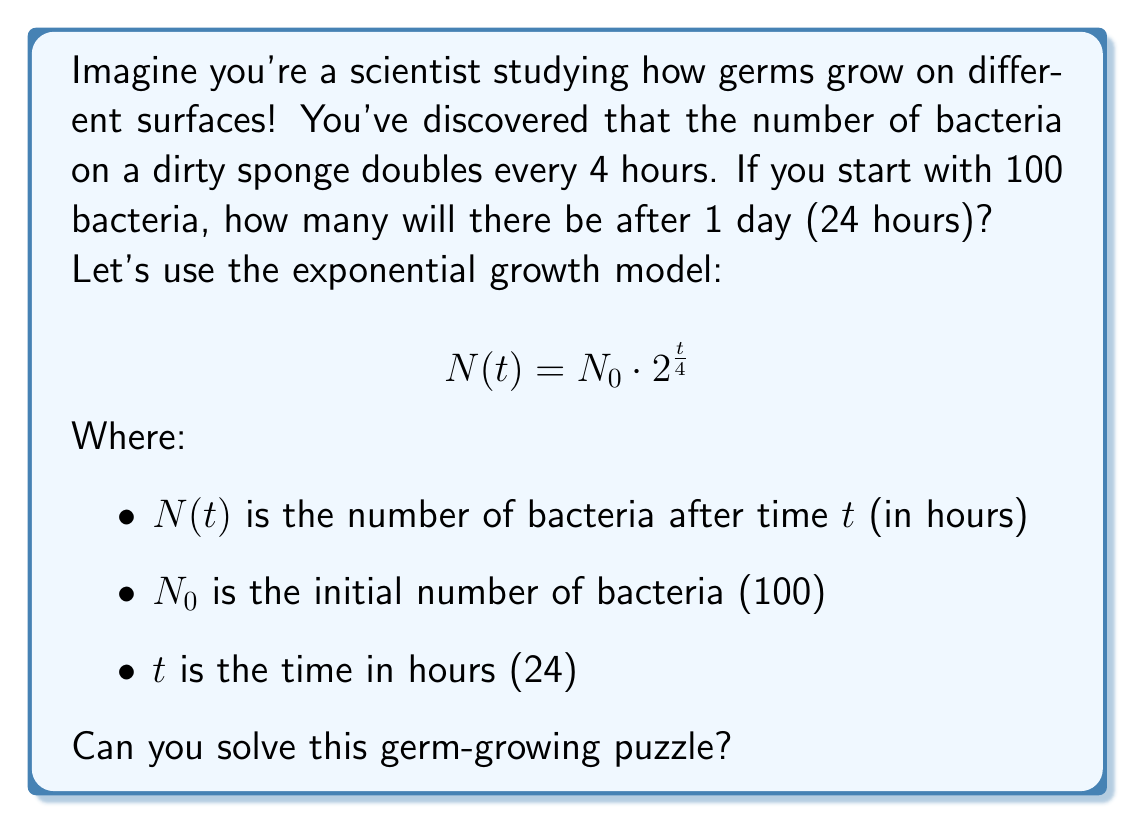Solve this math problem. Let's solve this step-by-step:

1) We start with the exponential growth model:
   $$N(t) = N_0 \cdot 2^{\frac{t}{4}}$$

2) We know:
   $N_0 = 100$ (initial number of bacteria)
   $t = 24$ hours (1 day)

3) Let's substitute these values into our equation:
   $$N(24) = 100 \cdot 2^{\frac{24}{4}}$$

4) Simplify the exponent:
   $$N(24) = 100 \cdot 2^6$$

5) Calculate $2^6$:
   $$2^6 = 2 \times 2 \times 2 \times 2 \times 2 \times 2 = 64$$

6) Now our equation looks like:
   $$N(24) = 100 \cdot 64$$

7) Multiply:
   $$N(24) = 6400$$

So, after 24 hours, there will be 6400 bacteria on the sponge!
Answer: 6400 bacteria 